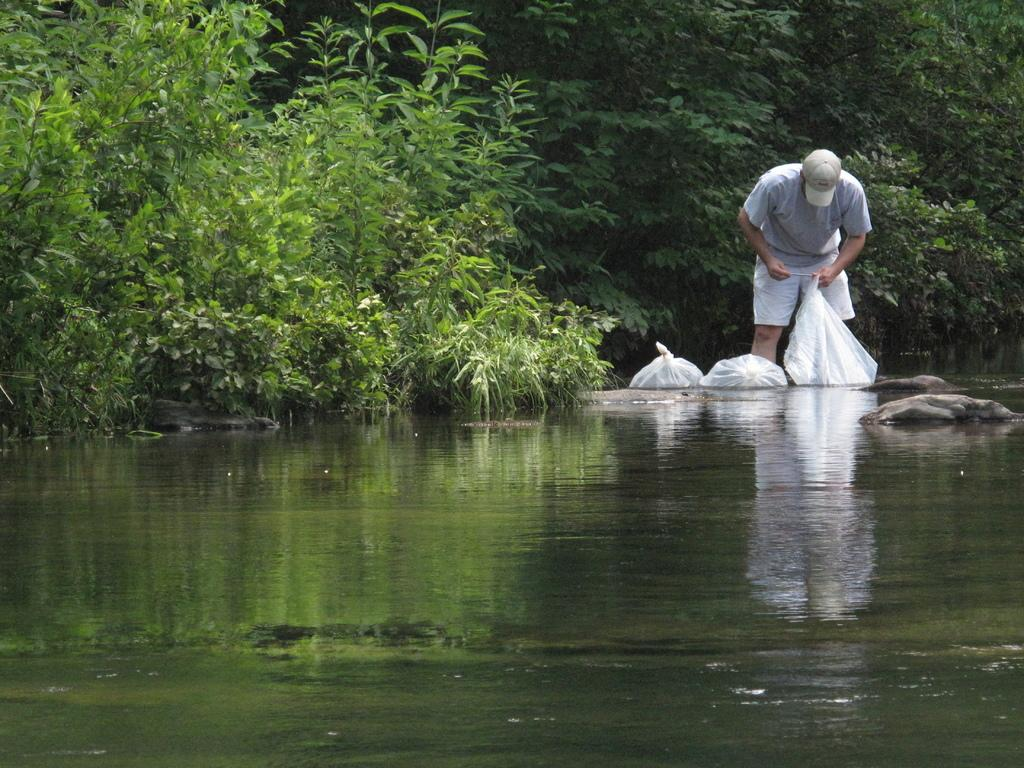What is the man in the image doing? The man is standing in the image and holding a cover. Are there any other covers visible in the image? Yes, there are additional covers beside the man. What type of natural elements can be seen in the image? There are stones, a water body, plants, and a group of trees visible in the image. How many geese are swimming in the water body in the image? There are no geese present in the image; it only features stones, a water body, plants, and a group of trees. What is the man blowing in the image? There is no indication in the image that the man is blowing anything. 